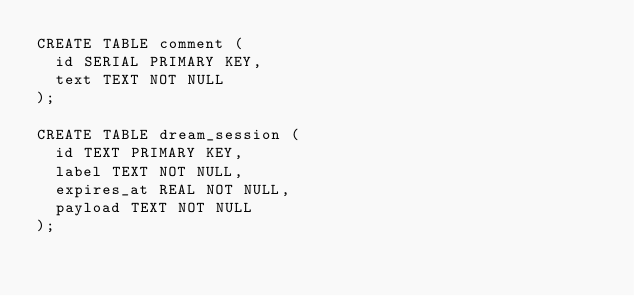Convert code to text. <code><loc_0><loc_0><loc_500><loc_500><_SQL_>CREATE TABLE comment (
  id SERIAL PRIMARY KEY,
  text TEXT NOT NULL
);

CREATE TABLE dream_session (
  id TEXT PRIMARY KEY,
  label TEXT NOT NULL,
  expires_at REAL NOT NULL,
  payload TEXT NOT NULL
);
</code> 